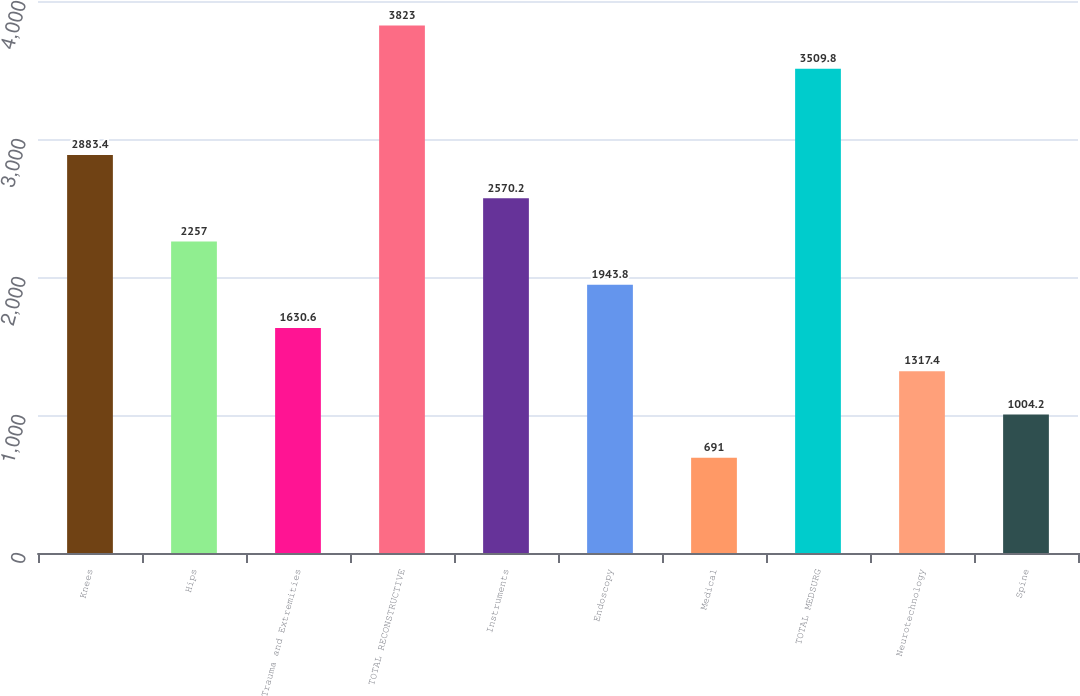<chart> <loc_0><loc_0><loc_500><loc_500><bar_chart><fcel>Knees<fcel>Hips<fcel>Trauma and Extremities<fcel>TOTAL RECONSTRUCTIVE<fcel>Instruments<fcel>Endoscopy<fcel>Medical<fcel>TOTAL MEDSURG<fcel>Neurotechnology<fcel>Spine<nl><fcel>2883.4<fcel>2257<fcel>1630.6<fcel>3823<fcel>2570.2<fcel>1943.8<fcel>691<fcel>3509.8<fcel>1317.4<fcel>1004.2<nl></chart> 